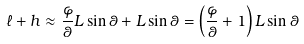<formula> <loc_0><loc_0><loc_500><loc_500>\ell + h \approx { \frac { \varphi } { \theta } } L \sin \theta + L \sin \theta = \left ( { \frac { \varphi } { \theta } } + 1 \right ) L \sin \theta</formula> 